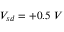Convert formula to latex. <formula><loc_0><loc_0><loc_500><loc_500>V _ { s d } = + 0 . 5 \ V</formula> 